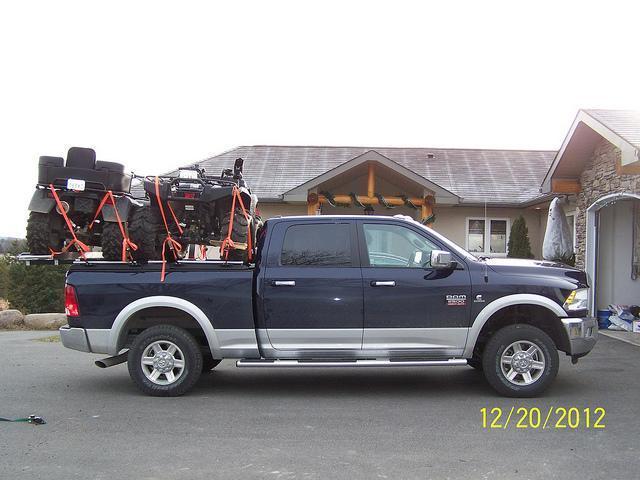How many vehicles are shown?
Give a very brief answer. 3. How many blue box by the red couch and located on the left of the coffee table ?
Give a very brief answer. 0. 